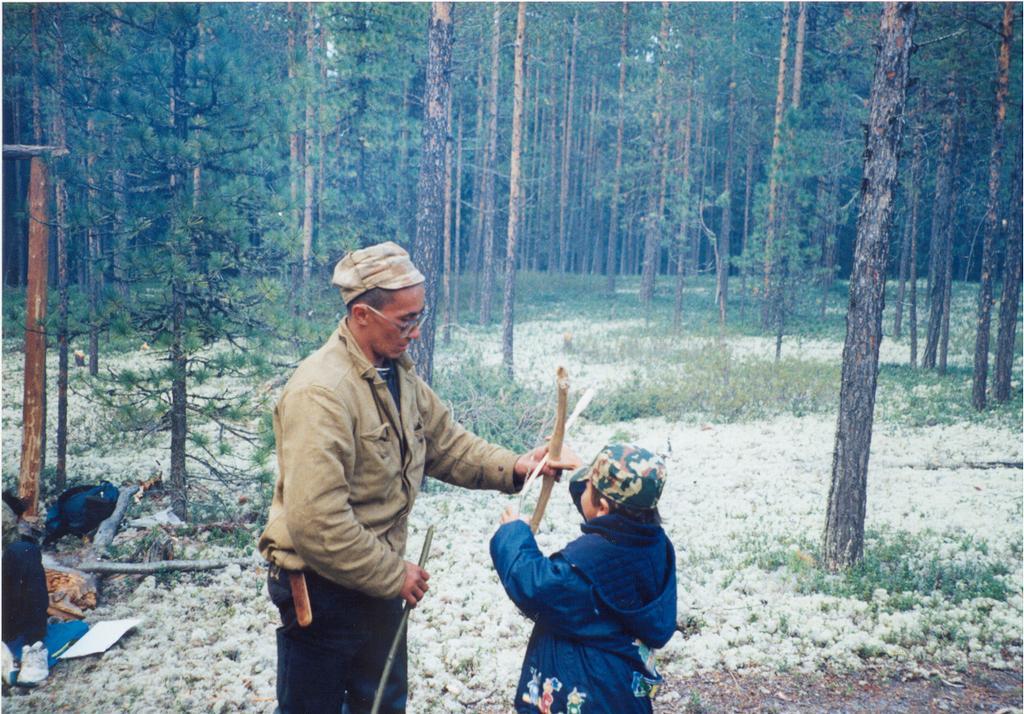How would you summarize this image in a sentence or two? In this picture I can see there is a man and a boy standing. They are holding wooden sticks and there is snow on the floor and in the backdrop there are trees. 